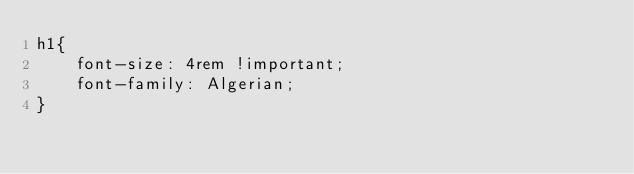Convert code to text. <code><loc_0><loc_0><loc_500><loc_500><_CSS_>h1{
    font-size: 4rem !important;
    font-family: Algerian;
}</code> 